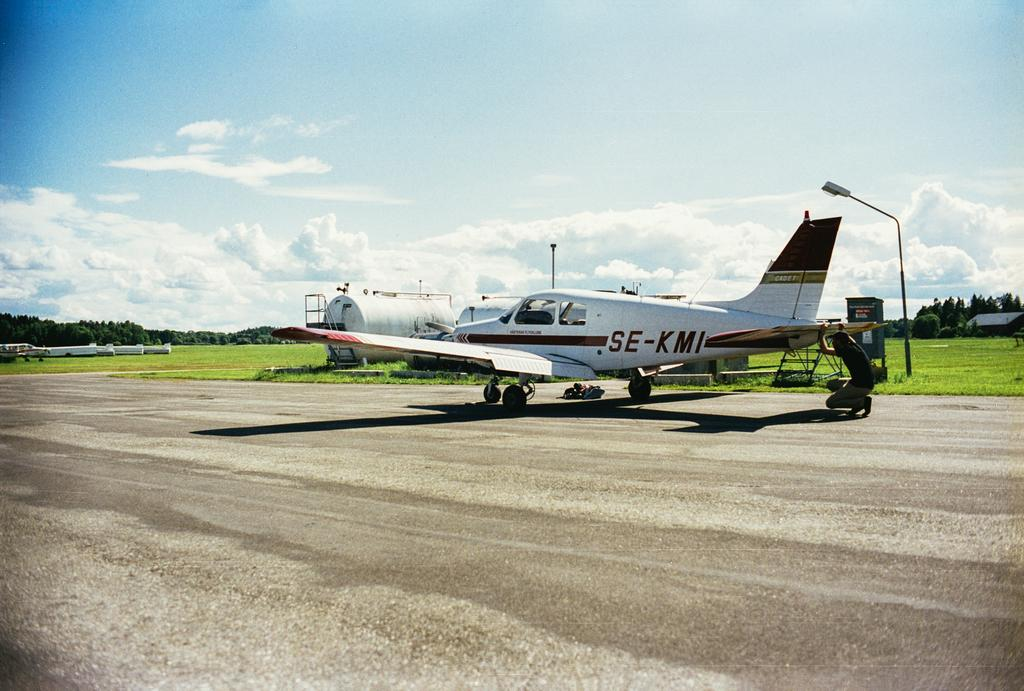<image>
Offer a succinct explanation of the picture presented. A small plane with a label SE-KMI is parked on an empty runaway. 